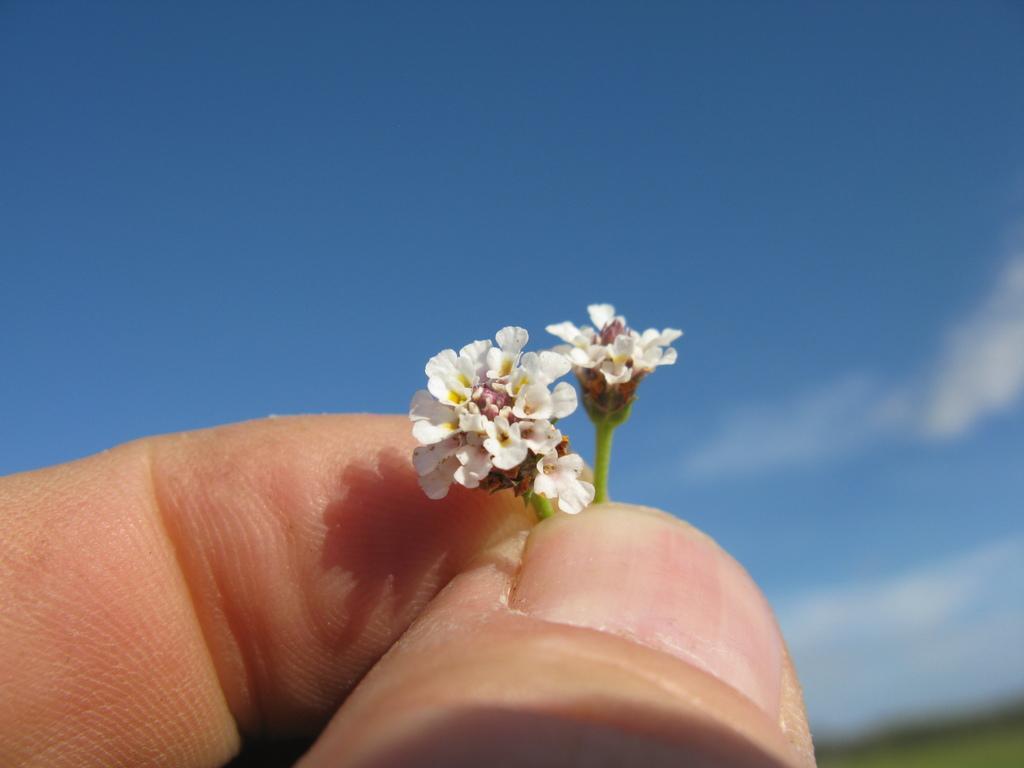Describe this image in one or two sentences. In this picture I can see fingers of a person holding two tiny flowers, and in the background there is the sky. 